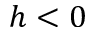Convert formula to latex. <formula><loc_0><loc_0><loc_500><loc_500>h < 0</formula> 